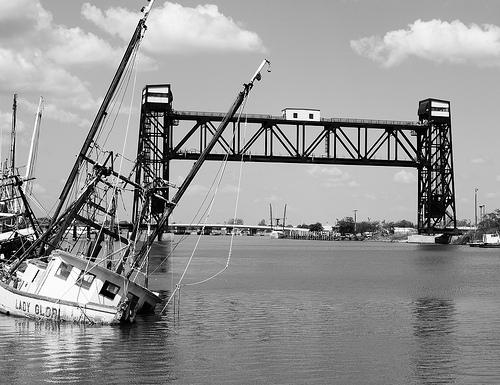Question: when will it sink?
Choices:
A. When it is full of water.
B. Later.
C. Tomorrow.
D. Soon.
Answer with the letter. Answer: A Question: how does the bridge rise and fall?
Choices:
A. Draw bridge.
B. Electrically.
C. Horse and chain.
D. Motors and pulleys.
Answer with the letter. Answer: D Question: who raise the bridge?
Choices:
A. The engineer.
B. A bridge tender.
C. The bridge Captain.
D. The bridge watcher.
Answer with the letter. Answer: B Question: what crosses over the bridge?
Choices:
A. A bus.
B. A car.
C. Rail traffic.
D. A semi.
Answer with the letter. Answer: C 